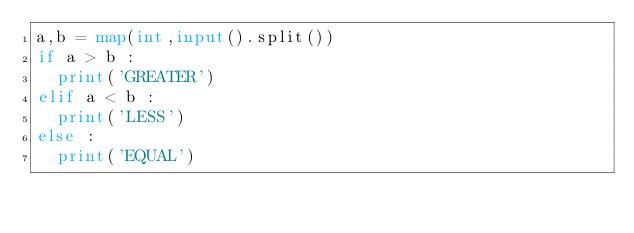<code> <loc_0><loc_0><loc_500><loc_500><_Python_>a,b = map(int,input().split())
if a > b :
  print('GREATER')
elif a < b :
  print('LESS')
else :
  print('EQUAL')</code> 